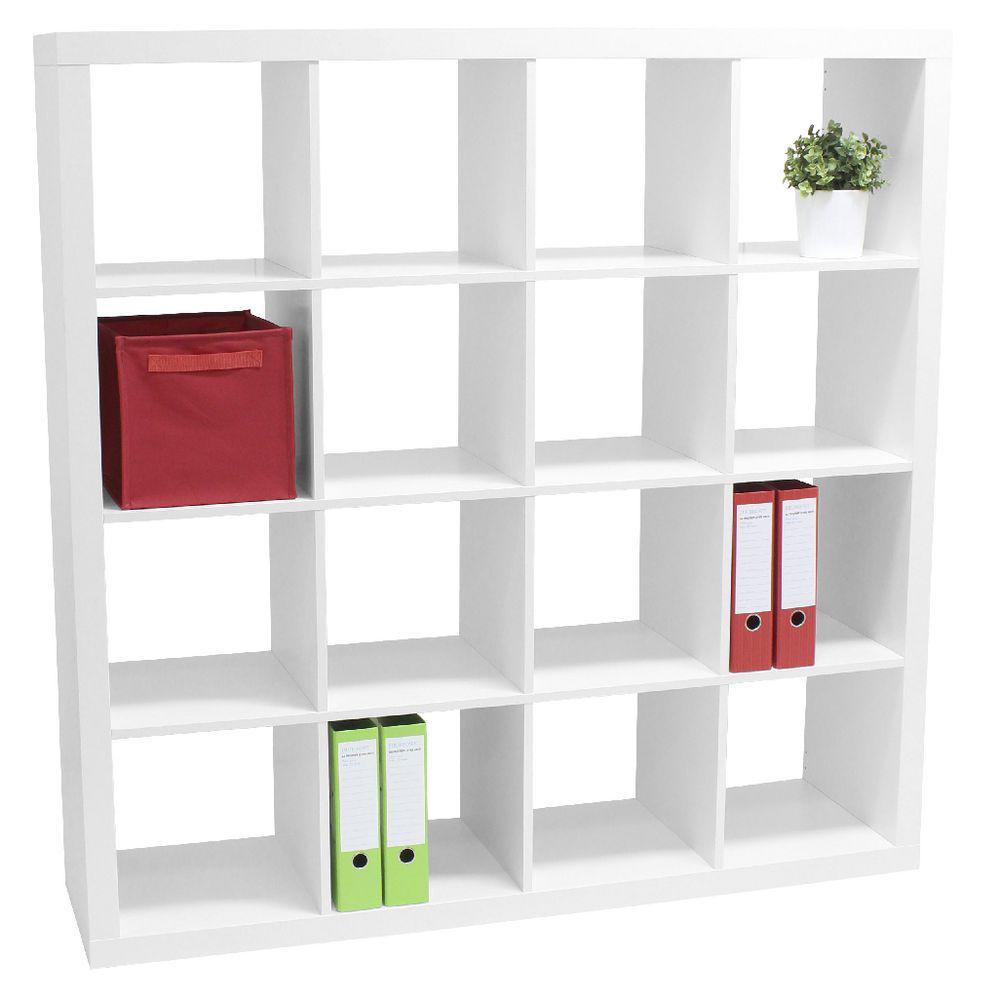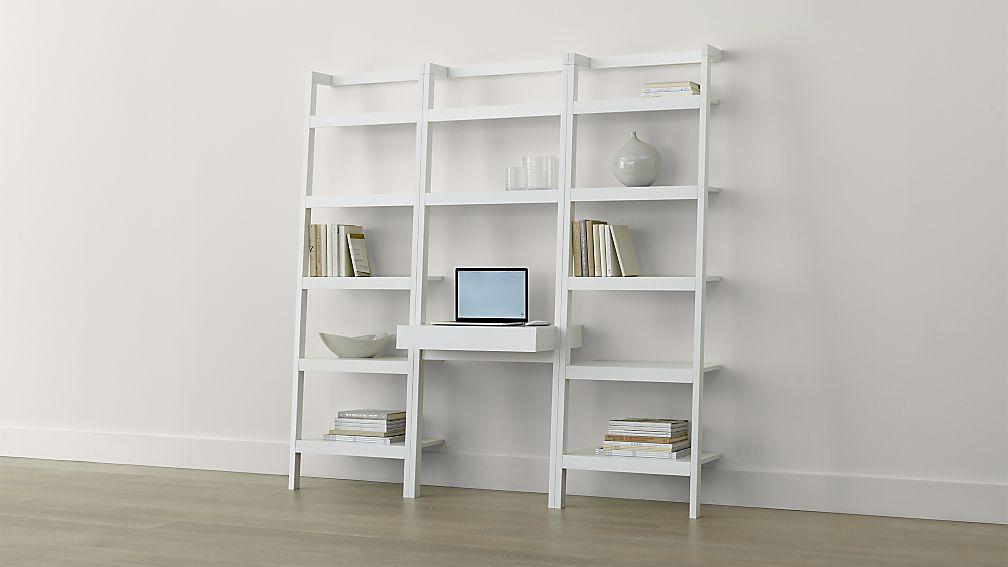The first image is the image on the left, the second image is the image on the right. Analyze the images presented: Is the assertion "The shelf unit in the left image can stand on its own." valid? Answer yes or no. Yes. The first image is the image on the left, the second image is the image on the right. Evaluate the accuracy of this statement regarding the images: "The right image features a white bookcase with three vertical rows of shelves, which is backless and leans against a wall.". Is it true? Answer yes or no. Yes. 